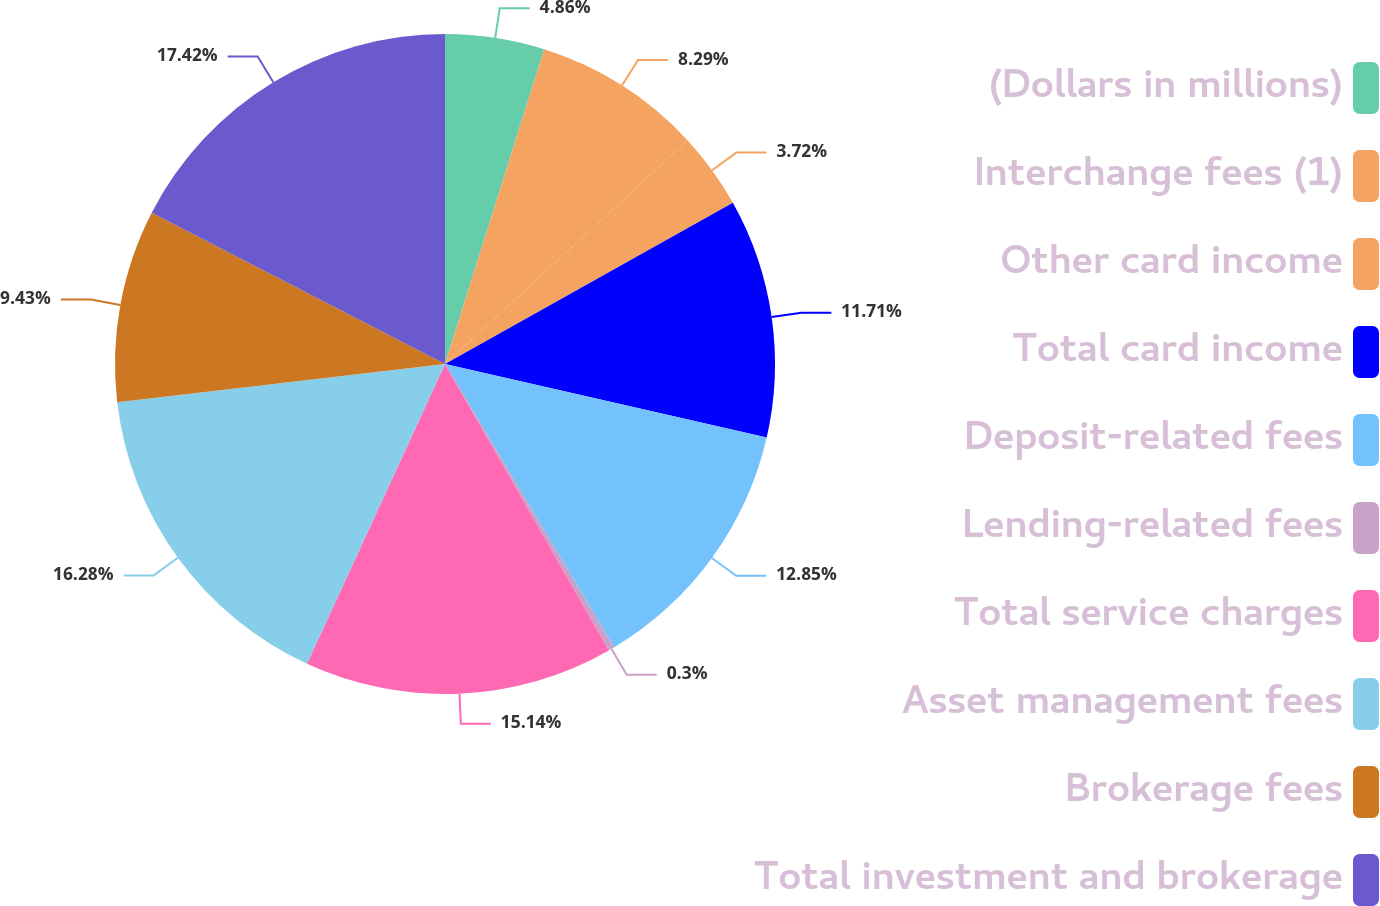Convert chart. <chart><loc_0><loc_0><loc_500><loc_500><pie_chart><fcel>(Dollars in millions)<fcel>Interchange fees (1)<fcel>Other card income<fcel>Total card income<fcel>Deposit-related fees<fcel>Lending-related fees<fcel>Total service charges<fcel>Asset management fees<fcel>Brokerage fees<fcel>Total investment and brokerage<nl><fcel>4.86%<fcel>8.29%<fcel>3.72%<fcel>11.71%<fcel>12.85%<fcel>0.3%<fcel>15.14%<fcel>16.28%<fcel>9.43%<fcel>17.42%<nl></chart> 